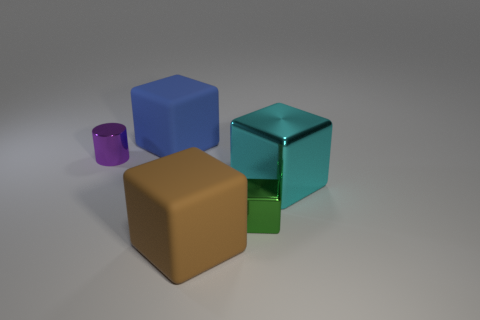What is the size of the shiny thing that is left of the blue matte object?
Offer a terse response. Small. What number of cyan things are made of the same material as the small green cube?
Make the answer very short. 1. There is a large rubber thing that is behind the big brown rubber block; does it have the same shape as the large metallic object?
Your response must be concise. Yes. There is a tiny shiny thing that is behind the big cyan metallic object; what shape is it?
Your answer should be compact. Cylinder. What is the material of the cylinder?
Provide a succinct answer. Metal. There is a cylinder that is the same size as the green metallic block; what is its color?
Keep it short and to the point. Purple. Is the shape of the blue rubber object the same as the brown matte object?
Your answer should be very brief. Yes. There is a thing that is on the right side of the small cylinder and left of the big brown matte object; what material is it?
Ensure brevity in your answer.  Rubber. What is the size of the purple object?
Offer a terse response. Small. What color is the other shiny object that is the same shape as the small green thing?
Make the answer very short. Cyan. 